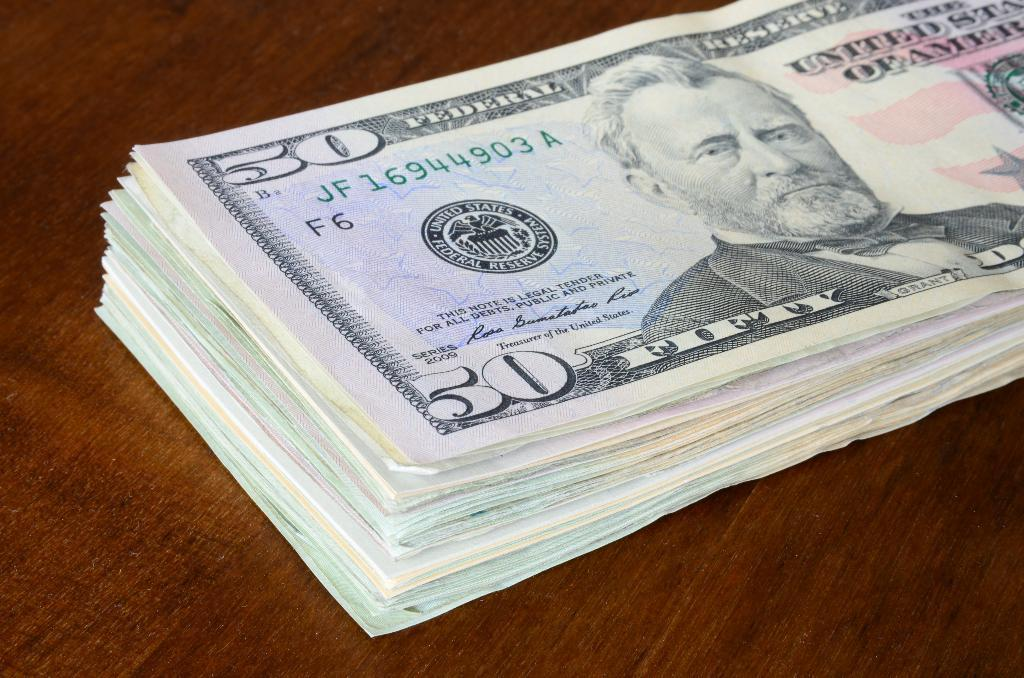What is the main subject of the image? The main subject of the image is a bunch of currency. What is the currency placed on in the image? The currency is on a wooden surface in the image. What type of crate is visible in the image? There is no crate present in the image. What direction is the rail heading in the image? There is no rail present in the image. 